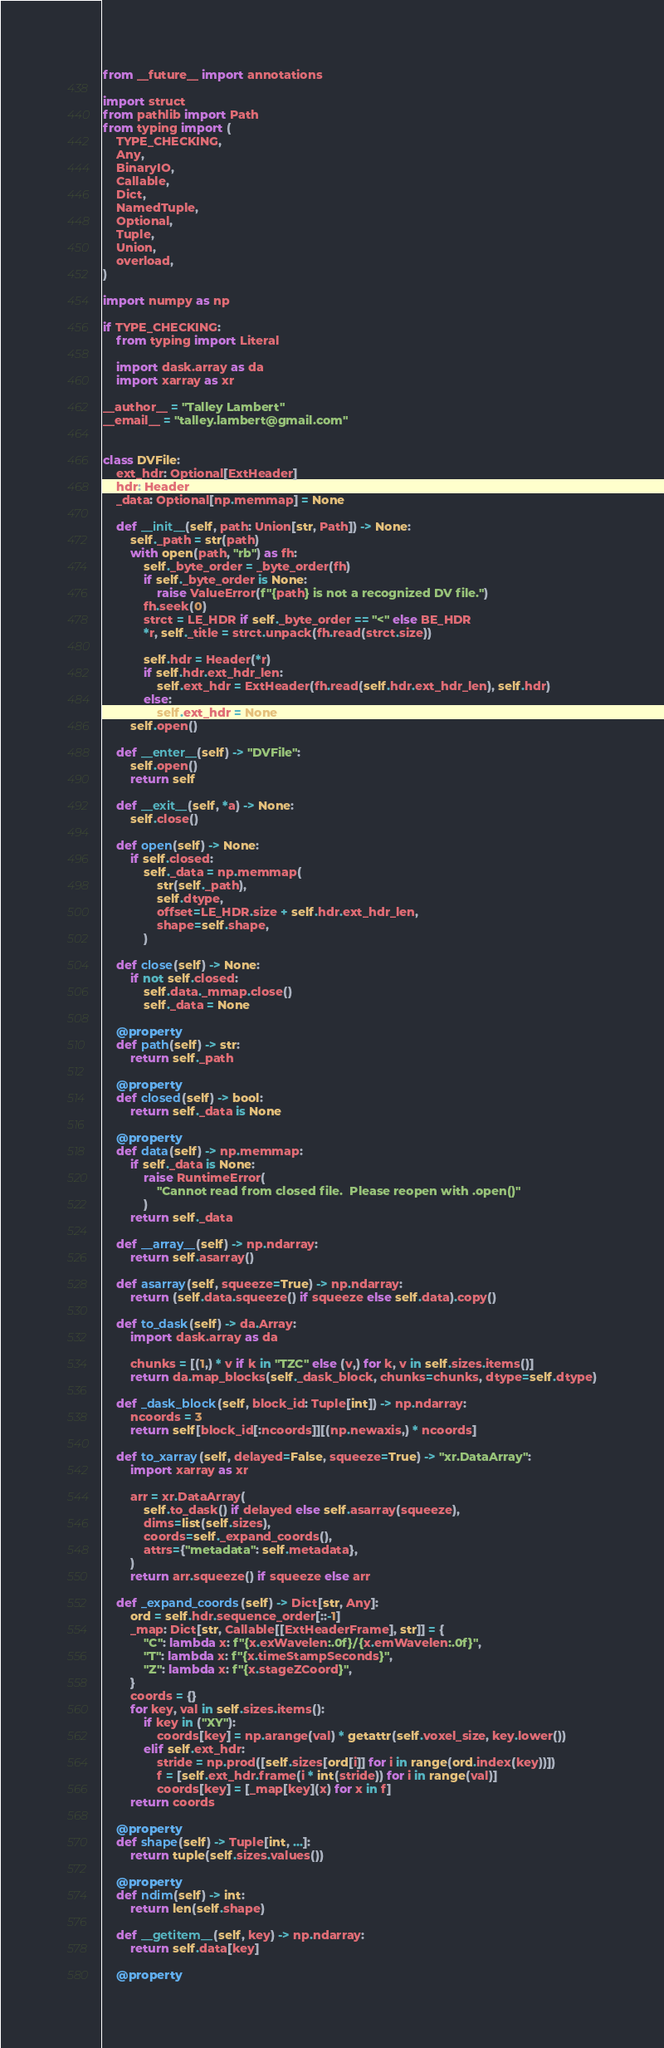Convert code to text. <code><loc_0><loc_0><loc_500><loc_500><_Python_>from __future__ import annotations

import struct
from pathlib import Path
from typing import (
    TYPE_CHECKING,
    Any,
    BinaryIO,
    Callable,
    Dict,
    NamedTuple,
    Optional,
    Tuple,
    Union,
    overload,
)

import numpy as np

if TYPE_CHECKING:
    from typing import Literal

    import dask.array as da
    import xarray as xr

__author__ = "Talley Lambert"
__email__ = "talley.lambert@gmail.com"


class DVFile:
    ext_hdr: Optional[ExtHeader]
    hdr: Header
    _data: Optional[np.memmap] = None

    def __init__(self, path: Union[str, Path]) -> None:
        self._path = str(path)
        with open(path, "rb") as fh:
            self._byte_order = _byte_order(fh)
            if self._byte_order is None:
                raise ValueError(f"{path} is not a recognized DV file.")
            fh.seek(0)
            strct = LE_HDR if self._byte_order == "<" else BE_HDR
            *r, self._title = strct.unpack(fh.read(strct.size))

            self.hdr = Header(*r)
            if self.hdr.ext_hdr_len:
                self.ext_hdr = ExtHeader(fh.read(self.hdr.ext_hdr_len), self.hdr)
            else:
                self.ext_hdr = None
        self.open()

    def __enter__(self) -> "DVFile":
        self.open()
        return self

    def __exit__(self, *a) -> None:
        self.close()

    def open(self) -> None:
        if self.closed:
            self._data = np.memmap(
                str(self._path),
                self.dtype,
                offset=LE_HDR.size + self.hdr.ext_hdr_len,
                shape=self.shape,
            )

    def close(self) -> None:
        if not self.closed:
            self.data._mmap.close()
            self._data = None

    @property
    def path(self) -> str:
        return self._path

    @property
    def closed(self) -> bool:
        return self._data is None

    @property
    def data(self) -> np.memmap:
        if self._data is None:
            raise RuntimeError(
                "Cannot read from closed file.  Please reopen with .open()"
            )
        return self._data

    def __array__(self) -> np.ndarray:
        return self.asarray()

    def asarray(self, squeeze=True) -> np.ndarray:
        return (self.data.squeeze() if squeeze else self.data).copy()

    def to_dask(self) -> da.Array:
        import dask.array as da

        chunks = [(1,) * v if k in "TZC" else (v,) for k, v in self.sizes.items()]
        return da.map_blocks(self._dask_block, chunks=chunks, dtype=self.dtype)

    def _dask_block(self, block_id: Tuple[int]) -> np.ndarray:
        ncoords = 3
        return self[block_id[:ncoords]][(np.newaxis,) * ncoords]

    def to_xarray(self, delayed=False, squeeze=True) -> "xr.DataArray":
        import xarray as xr

        arr = xr.DataArray(
            self.to_dask() if delayed else self.asarray(squeeze),
            dims=list(self.sizes),
            coords=self._expand_coords(),
            attrs={"metadata": self.metadata},
        )
        return arr.squeeze() if squeeze else arr

    def _expand_coords(self) -> Dict[str, Any]:
        ord = self.hdr.sequence_order[::-1]
        _map: Dict[str, Callable[[ExtHeaderFrame], str]] = {
            "C": lambda x: f"{x.exWavelen:.0f}/{x.emWavelen:.0f}",
            "T": lambda x: f"{x.timeStampSeconds}",
            "Z": lambda x: f"{x.stageZCoord}",
        }
        coords = {}
        for key, val in self.sizes.items():
            if key in ("XY"):
                coords[key] = np.arange(val) * getattr(self.voxel_size, key.lower())
            elif self.ext_hdr:
                stride = np.prod([self.sizes[ord[i]] for i in range(ord.index(key))])
                f = [self.ext_hdr.frame(i * int(stride)) for i in range(val)]
                coords[key] = [_map[key](x) for x in f]
        return coords

    @property
    def shape(self) -> Tuple[int, ...]:
        return tuple(self.sizes.values())

    @property
    def ndim(self) -> int:
        return len(self.shape)

    def __getitem__(self, key) -> np.ndarray:
        return self.data[key]

    @property</code> 